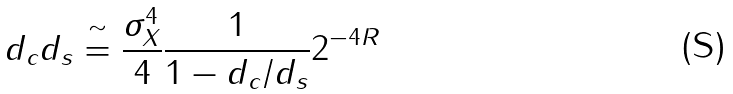<formula> <loc_0><loc_0><loc_500><loc_500>d _ { c } d _ { s } \stackrel { \sim } { = } \frac { \sigma _ { X } ^ { 4 } } { 4 } \frac { 1 } { 1 - d _ { c } / d _ { s } } 2 ^ { - 4 R }</formula> 